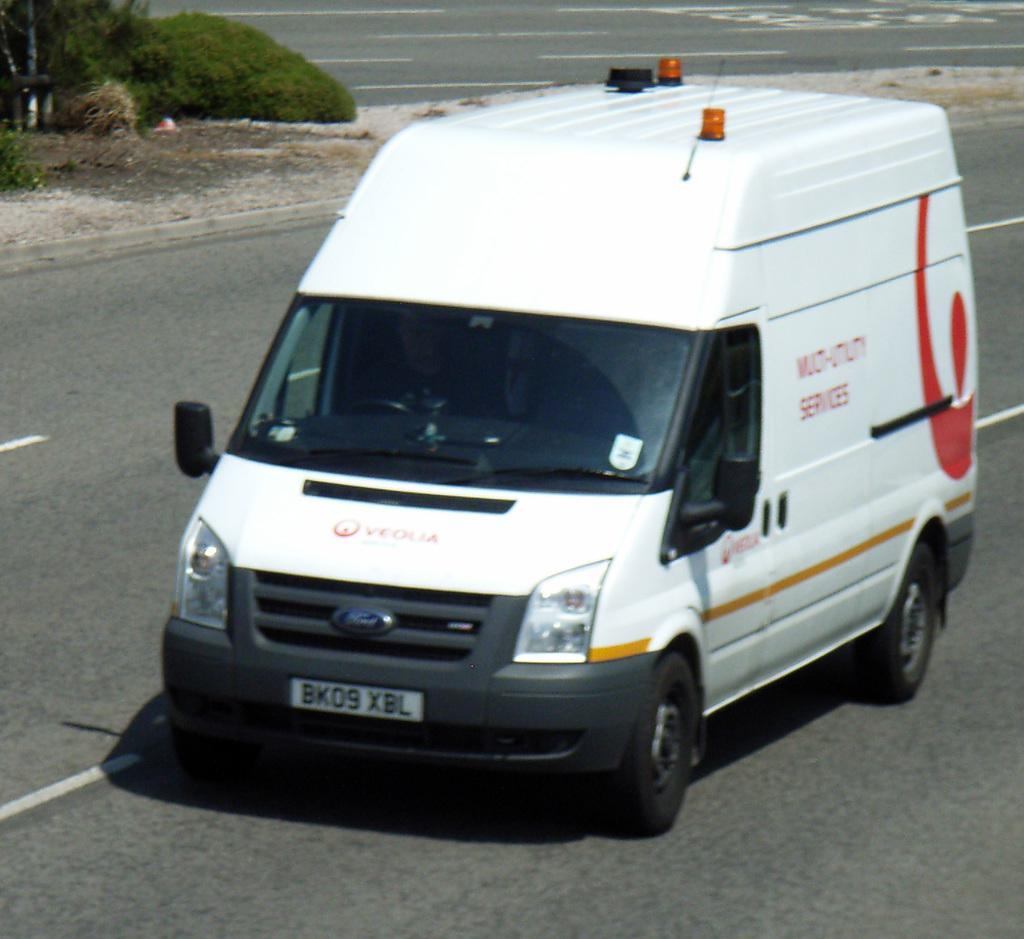<image>
Write a terse but informative summary of the picture. A white Veolia van driving on the road. 